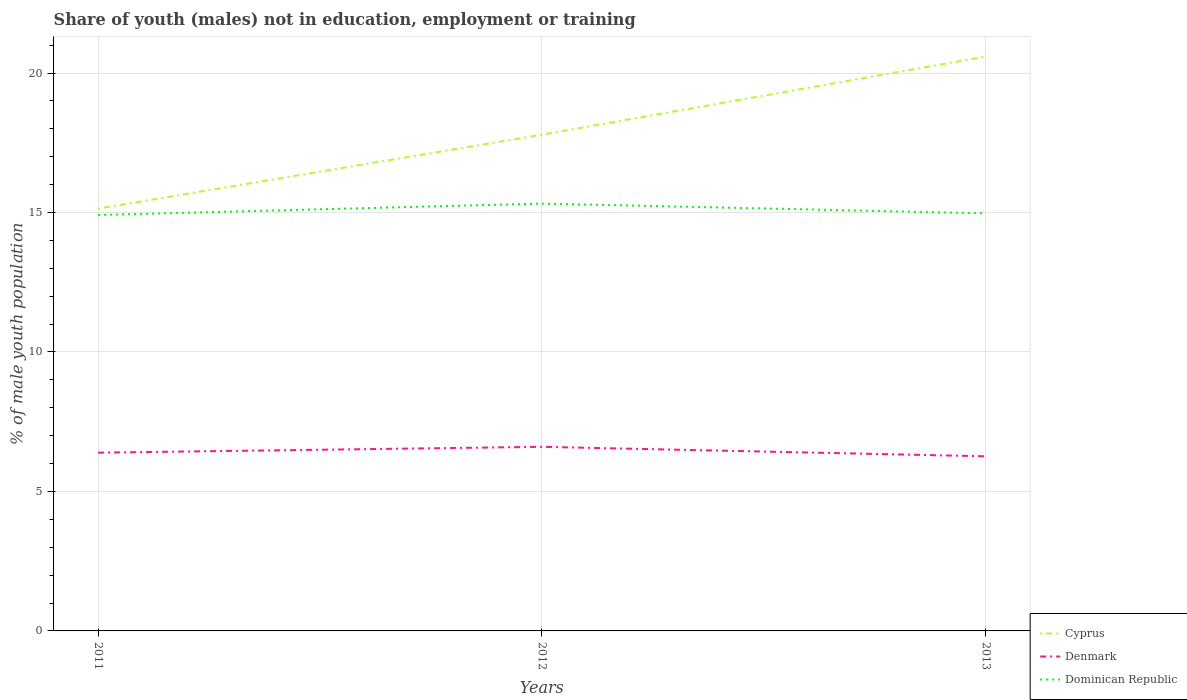How many different coloured lines are there?
Provide a succinct answer. 3. Across all years, what is the maximum percentage of unemployed males population in in Dominican Republic?
Your answer should be compact. 14.91. In which year was the percentage of unemployed males population in in Dominican Republic maximum?
Your answer should be very brief. 2011. What is the total percentage of unemployed males population in in Cyprus in the graph?
Offer a very short reply. -5.45. What is the difference between the highest and the second highest percentage of unemployed males population in in Dominican Republic?
Your answer should be compact. 0.41. What is the difference between the highest and the lowest percentage of unemployed males population in in Dominican Republic?
Your answer should be very brief. 1. Is the percentage of unemployed males population in in Denmark strictly greater than the percentage of unemployed males population in in Dominican Republic over the years?
Make the answer very short. Yes. How many lines are there?
Your answer should be very brief. 3. How many years are there in the graph?
Offer a terse response. 3. What is the difference between two consecutive major ticks on the Y-axis?
Offer a very short reply. 5. Are the values on the major ticks of Y-axis written in scientific E-notation?
Give a very brief answer. No. Does the graph contain grids?
Keep it short and to the point. Yes. Where does the legend appear in the graph?
Offer a very short reply. Bottom right. How many legend labels are there?
Your response must be concise. 3. What is the title of the graph?
Your response must be concise. Share of youth (males) not in education, employment or training. Does "Puerto Rico" appear as one of the legend labels in the graph?
Offer a very short reply. No. What is the label or title of the X-axis?
Keep it short and to the point. Years. What is the label or title of the Y-axis?
Offer a terse response. % of male youth population. What is the % of male youth population of Cyprus in 2011?
Keep it short and to the point. 15.14. What is the % of male youth population of Denmark in 2011?
Ensure brevity in your answer.  6.39. What is the % of male youth population of Dominican Republic in 2011?
Make the answer very short. 14.91. What is the % of male youth population in Cyprus in 2012?
Your answer should be very brief. 17.79. What is the % of male youth population in Denmark in 2012?
Offer a very short reply. 6.6. What is the % of male youth population of Dominican Republic in 2012?
Provide a short and direct response. 15.32. What is the % of male youth population in Cyprus in 2013?
Your answer should be compact. 20.59. What is the % of male youth population in Denmark in 2013?
Keep it short and to the point. 6.26. What is the % of male youth population of Dominican Republic in 2013?
Keep it short and to the point. 14.97. Across all years, what is the maximum % of male youth population in Cyprus?
Your answer should be compact. 20.59. Across all years, what is the maximum % of male youth population in Denmark?
Offer a very short reply. 6.6. Across all years, what is the maximum % of male youth population in Dominican Republic?
Your answer should be compact. 15.32. Across all years, what is the minimum % of male youth population in Cyprus?
Ensure brevity in your answer.  15.14. Across all years, what is the minimum % of male youth population in Denmark?
Offer a very short reply. 6.26. Across all years, what is the minimum % of male youth population in Dominican Republic?
Provide a short and direct response. 14.91. What is the total % of male youth population in Cyprus in the graph?
Keep it short and to the point. 53.52. What is the total % of male youth population in Denmark in the graph?
Your answer should be very brief. 19.25. What is the total % of male youth population in Dominican Republic in the graph?
Give a very brief answer. 45.2. What is the difference between the % of male youth population of Cyprus in 2011 and that in 2012?
Your response must be concise. -2.65. What is the difference between the % of male youth population in Denmark in 2011 and that in 2012?
Ensure brevity in your answer.  -0.21. What is the difference between the % of male youth population in Dominican Republic in 2011 and that in 2012?
Give a very brief answer. -0.41. What is the difference between the % of male youth population of Cyprus in 2011 and that in 2013?
Ensure brevity in your answer.  -5.45. What is the difference between the % of male youth population of Denmark in 2011 and that in 2013?
Ensure brevity in your answer.  0.13. What is the difference between the % of male youth population of Dominican Republic in 2011 and that in 2013?
Make the answer very short. -0.06. What is the difference between the % of male youth population in Denmark in 2012 and that in 2013?
Provide a short and direct response. 0.34. What is the difference between the % of male youth population in Cyprus in 2011 and the % of male youth population in Denmark in 2012?
Ensure brevity in your answer.  8.54. What is the difference between the % of male youth population of Cyprus in 2011 and the % of male youth population of Dominican Republic in 2012?
Make the answer very short. -0.18. What is the difference between the % of male youth population of Denmark in 2011 and the % of male youth population of Dominican Republic in 2012?
Provide a succinct answer. -8.93. What is the difference between the % of male youth population in Cyprus in 2011 and the % of male youth population in Denmark in 2013?
Offer a terse response. 8.88. What is the difference between the % of male youth population of Cyprus in 2011 and the % of male youth population of Dominican Republic in 2013?
Provide a succinct answer. 0.17. What is the difference between the % of male youth population of Denmark in 2011 and the % of male youth population of Dominican Republic in 2013?
Your answer should be compact. -8.58. What is the difference between the % of male youth population of Cyprus in 2012 and the % of male youth population of Denmark in 2013?
Keep it short and to the point. 11.53. What is the difference between the % of male youth population in Cyprus in 2012 and the % of male youth population in Dominican Republic in 2013?
Keep it short and to the point. 2.82. What is the difference between the % of male youth population of Denmark in 2012 and the % of male youth population of Dominican Republic in 2013?
Offer a very short reply. -8.37. What is the average % of male youth population of Cyprus per year?
Offer a terse response. 17.84. What is the average % of male youth population of Denmark per year?
Provide a succinct answer. 6.42. What is the average % of male youth population in Dominican Republic per year?
Your answer should be very brief. 15.07. In the year 2011, what is the difference between the % of male youth population of Cyprus and % of male youth population of Denmark?
Offer a terse response. 8.75. In the year 2011, what is the difference between the % of male youth population of Cyprus and % of male youth population of Dominican Republic?
Give a very brief answer. 0.23. In the year 2011, what is the difference between the % of male youth population in Denmark and % of male youth population in Dominican Republic?
Your response must be concise. -8.52. In the year 2012, what is the difference between the % of male youth population of Cyprus and % of male youth population of Denmark?
Provide a succinct answer. 11.19. In the year 2012, what is the difference between the % of male youth population in Cyprus and % of male youth population in Dominican Republic?
Provide a succinct answer. 2.47. In the year 2012, what is the difference between the % of male youth population of Denmark and % of male youth population of Dominican Republic?
Provide a succinct answer. -8.72. In the year 2013, what is the difference between the % of male youth population of Cyprus and % of male youth population of Denmark?
Ensure brevity in your answer.  14.33. In the year 2013, what is the difference between the % of male youth population of Cyprus and % of male youth population of Dominican Republic?
Keep it short and to the point. 5.62. In the year 2013, what is the difference between the % of male youth population in Denmark and % of male youth population in Dominican Republic?
Provide a short and direct response. -8.71. What is the ratio of the % of male youth population in Cyprus in 2011 to that in 2012?
Make the answer very short. 0.85. What is the ratio of the % of male youth population of Denmark in 2011 to that in 2012?
Give a very brief answer. 0.97. What is the ratio of the % of male youth population in Dominican Republic in 2011 to that in 2012?
Your answer should be compact. 0.97. What is the ratio of the % of male youth population of Cyprus in 2011 to that in 2013?
Make the answer very short. 0.74. What is the ratio of the % of male youth population of Denmark in 2011 to that in 2013?
Provide a succinct answer. 1.02. What is the ratio of the % of male youth population in Cyprus in 2012 to that in 2013?
Offer a terse response. 0.86. What is the ratio of the % of male youth population of Denmark in 2012 to that in 2013?
Provide a succinct answer. 1.05. What is the ratio of the % of male youth population of Dominican Republic in 2012 to that in 2013?
Ensure brevity in your answer.  1.02. What is the difference between the highest and the second highest % of male youth population of Cyprus?
Offer a terse response. 2.8. What is the difference between the highest and the second highest % of male youth population in Denmark?
Provide a short and direct response. 0.21. What is the difference between the highest and the second highest % of male youth population in Dominican Republic?
Make the answer very short. 0.35. What is the difference between the highest and the lowest % of male youth population of Cyprus?
Make the answer very short. 5.45. What is the difference between the highest and the lowest % of male youth population in Denmark?
Provide a short and direct response. 0.34. What is the difference between the highest and the lowest % of male youth population in Dominican Republic?
Provide a succinct answer. 0.41. 